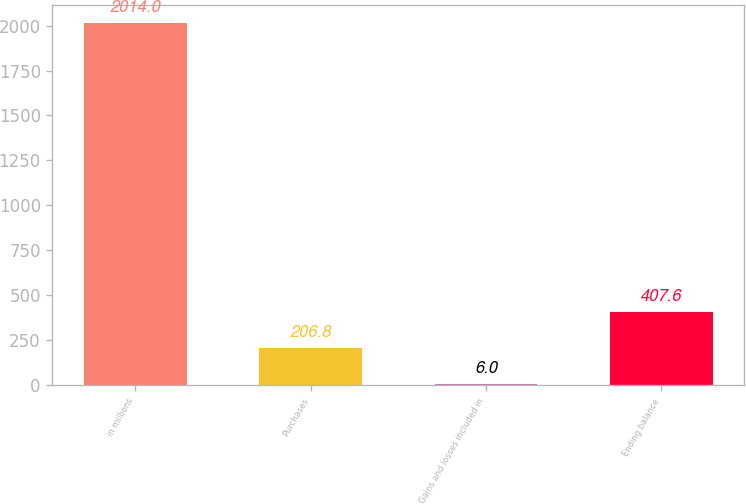Convert chart to OTSL. <chart><loc_0><loc_0><loc_500><loc_500><bar_chart><fcel>in millions<fcel>Purchases<fcel>Gains and losses included in<fcel>Ending balance<nl><fcel>2014<fcel>206.8<fcel>6<fcel>407.6<nl></chart> 